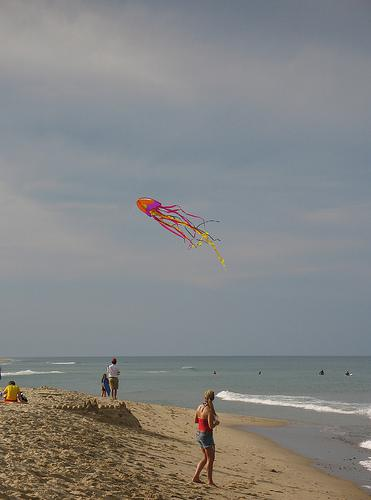Question: where was the photo taken?
Choices:
A. Mountains.
B. The city.
C. The beach.
D. In the house.
Answer with the letter. Answer: C Question: what are the people standing on?
Choices:
A. Grass.
B. Dirt.
C. Sand.
D. Gravel.
Answer with the letter. Answer: C Question: when was the photo taken?
Choices:
A. Night time.
B. Afternoon.
C. Day time.
D. Midnight.
Answer with the letter. Answer: C 